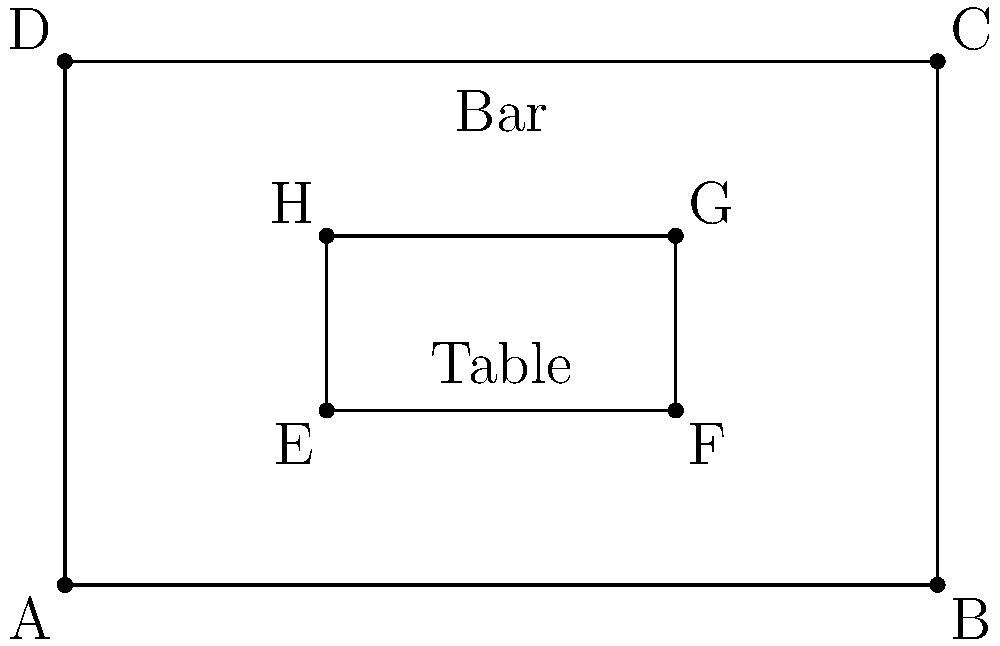In your pub, you want to maximize seating capacity while maintaining a comfortable atmosphere. The pub's main area is rectangular, measuring 10 meters by 6 meters. Each table is 4 meters by 2 meters and requires a 1-meter clearance on all sides for comfortable seating and movement. What is the maximum number of tables that can fit in the pub's main area without overlapping or violating the clearance requirement? To solve this problem, we'll follow these steps:

1. Calculate the effective space needed for each table:
   - Table size: 4m x 2m
   - Clearance on all sides: 1m
   - Effective space: (4m + 2m) x (2m + 2m) = 6m x 4m

2. Calculate the available space in the pub:
   - Pub dimensions: 10m x 6m

3. Determine how many tables can fit along the length:
   - Available length: 10m
   - Table effective length: 6m
   - Number of tables along length: $\lfloor 10 \div 6 \rfloor = 1$

4. Determine how many tables can fit along the width:
   - Available width: 6m
   - Table effective width: 4m
   - Number of tables along width: $\lfloor 6 \div 4 \rfloor = 1$

5. Calculate the total number of tables:
   - Total tables = Tables along length x Tables along width
   - Total tables = $1 \times 1 = 1$

Therefore, the maximum number of tables that can fit in the pub's main area while maintaining the required clearance is 1.
Answer: 1 table 